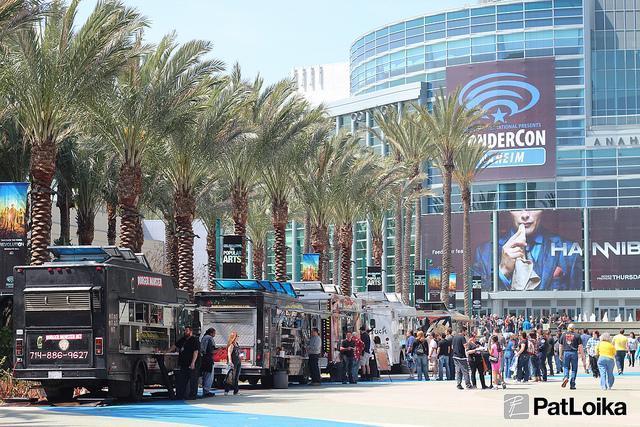How many trucks are in the photo?
Give a very brief answer. 3. How many people cutting the cake wear glasses?
Give a very brief answer. 0. 